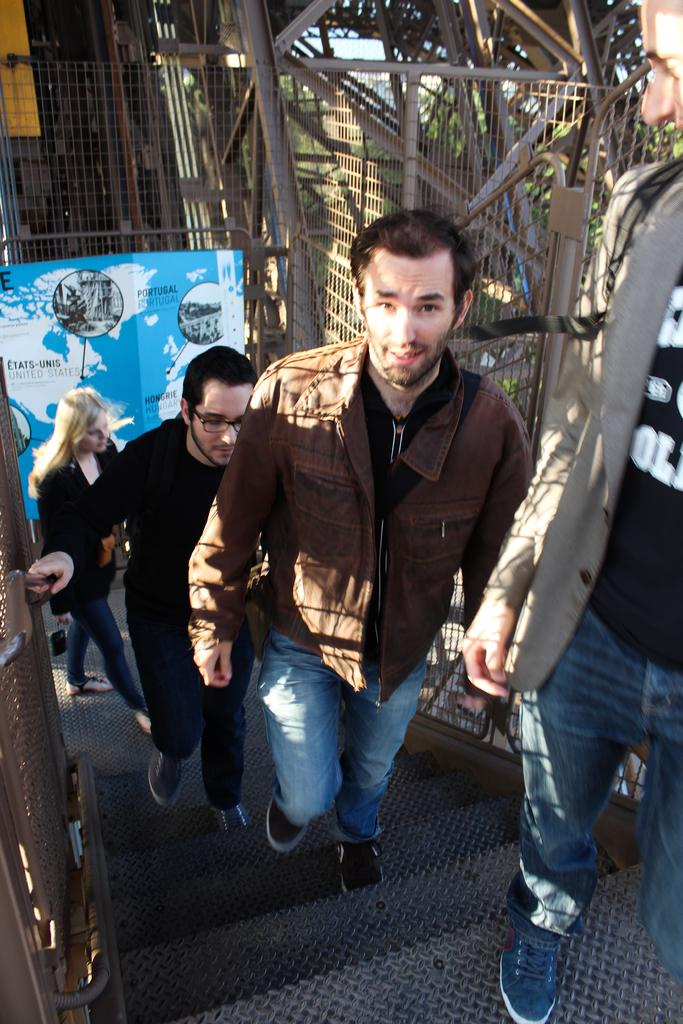What are the people in the image doing? The people in the image are climbing up the stairs. What can be seen hanging or displayed in the image? There is a banner in the image. What type of barrier is present in the image? There is a fence in the image. What can be seen in the distance in the image? Trees are visible in the background of the image. What type of leather is being used to make the kitty comfortable in the image? There is no kitty or leather present in the image. 